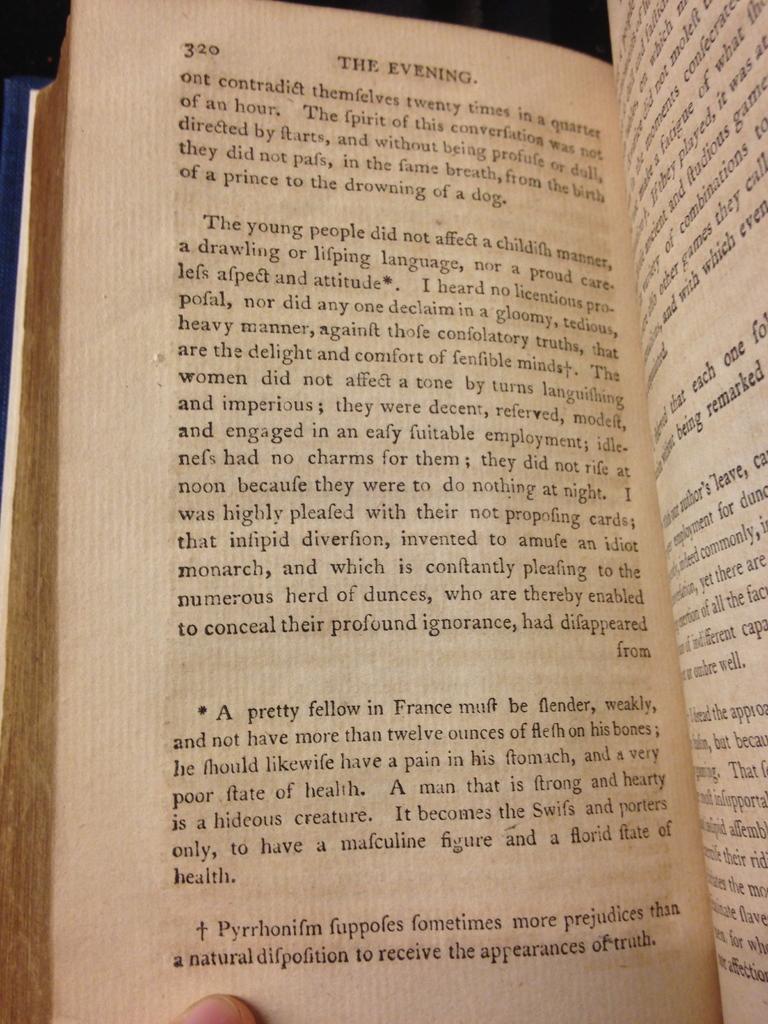What is the title of this book(or chapter)?
Provide a short and direct response. The evening. Is this a book?
Make the answer very short. Yes. 